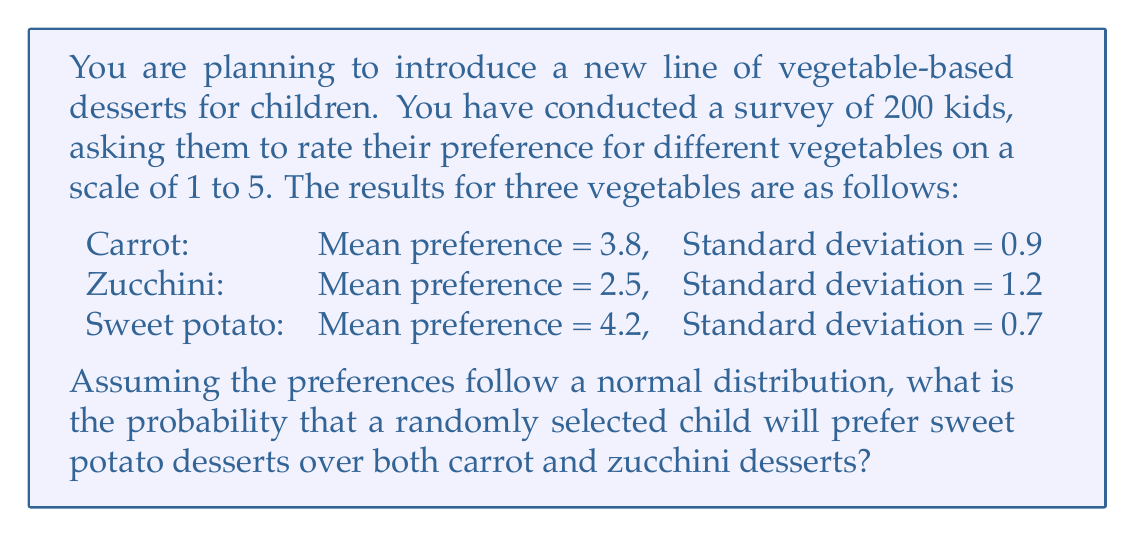Can you answer this question? To solve this problem, we need to follow these steps:

1. Calculate the probability that a child's preference for sweet potato is higher than their preference for carrot.
2. Calculate the probability that a child's preference for sweet potato is higher than their preference for zucchini.
3. Multiply these probabilities to get the probability of both events occurring simultaneously.

Step 1: Sweet potato vs. Carrot

We need to find $P(X_s - X_c > 0)$, where $X_s$ is the preference for sweet potato and $X_c$ is the preference for carrot.

The difference between two normal distributions is also normally distributed. The mean of the difference is the difference of the means, and the variance of the difference is the sum of the variances.

Mean difference: $\mu_d = 4.2 - 3.8 = 0.4$
Variance of difference: $\sigma_d^2 = 0.7^2 + 0.9^2 = 1.3$
Standard deviation of difference: $\sigma_d = \sqrt{1.3} \approx 1.14$

We can now calculate the z-score:
$z = \frac{0 - 0.4}{1.14} \approx -0.35$

Using a standard normal table or calculator, we find:
$P(X_s - X_c > 0) = P(Z > -0.35) \approx 0.6368$

Step 2: Sweet potato vs. Zucchini

Similarly, we calculate $P(X_s - X_z > 0)$:

Mean difference: $\mu_d = 4.2 - 2.5 = 1.7$
Variance of difference: $\sigma_d^2 = 0.7^2 + 1.2^2 = 1.93$
Standard deviation of difference: $\sigma_d = \sqrt{1.93} \approx 1.39$

Z-score: $z = \frac{0 - 1.7}{1.39} \approx -1.22$

$P(X_s - X_z > 0) = P(Z > -1.22) \approx 0.8888$

Step 3: Combining probabilities

Assuming independence between preferences, we multiply the probabilities:

$P(\text{Sweet potato preferred over both}) = 0.6368 \times 0.8888 \approx 0.5660$
Answer: The probability that a randomly selected child will prefer sweet potato desserts over both carrot and zucchini desserts is approximately 0.5660 or 56.60%. 